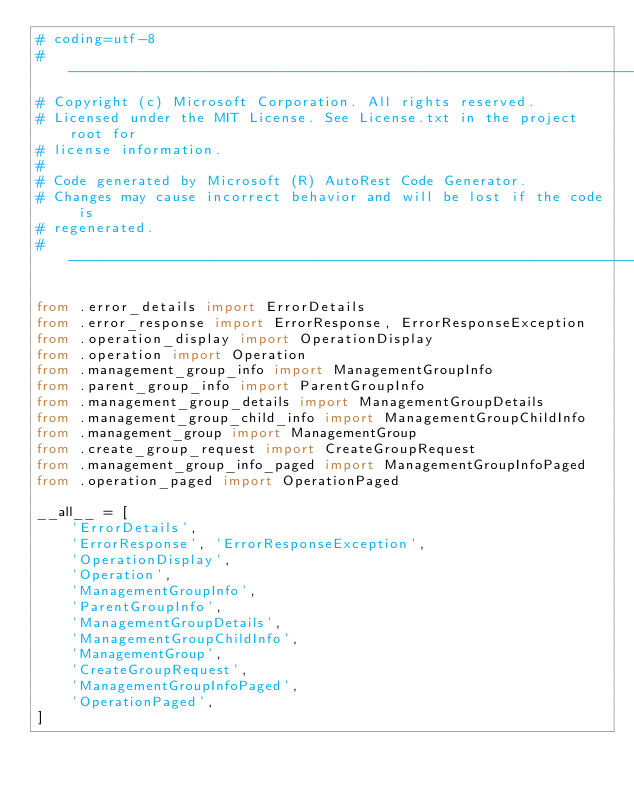<code> <loc_0><loc_0><loc_500><loc_500><_Python_># coding=utf-8
# --------------------------------------------------------------------------
# Copyright (c) Microsoft Corporation. All rights reserved.
# Licensed under the MIT License. See License.txt in the project root for
# license information.
#
# Code generated by Microsoft (R) AutoRest Code Generator.
# Changes may cause incorrect behavior and will be lost if the code is
# regenerated.
# --------------------------------------------------------------------------

from .error_details import ErrorDetails
from .error_response import ErrorResponse, ErrorResponseException
from .operation_display import OperationDisplay
from .operation import Operation
from .management_group_info import ManagementGroupInfo
from .parent_group_info import ParentGroupInfo
from .management_group_details import ManagementGroupDetails
from .management_group_child_info import ManagementGroupChildInfo
from .management_group import ManagementGroup
from .create_group_request import CreateGroupRequest
from .management_group_info_paged import ManagementGroupInfoPaged
from .operation_paged import OperationPaged

__all__ = [
    'ErrorDetails',
    'ErrorResponse', 'ErrorResponseException',
    'OperationDisplay',
    'Operation',
    'ManagementGroupInfo',
    'ParentGroupInfo',
    'ManagementGroupDetails',
    'ManagementGroupChildInfo',
    'ManagementGroup',
    'CreateGroupRequest',
    'ManagementGroupInfoPaged',
    'OperationPaged',
]
</code> 